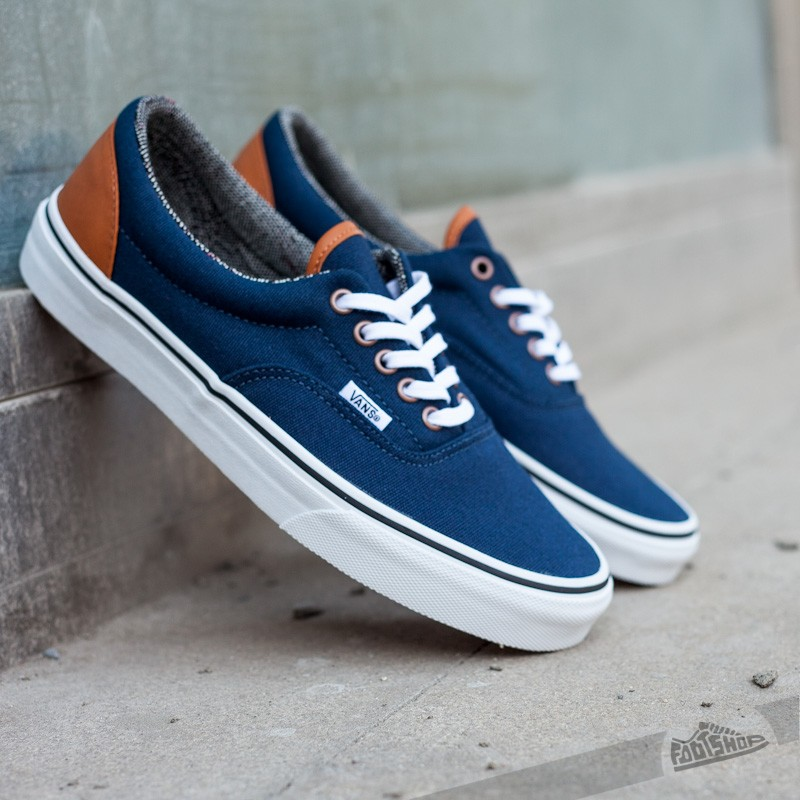Imagine these sneakers are empowered with self-lacing capabilities. What futuristic features could they have besides self-lacing? In a futuristic world where these sneakers have self-lacing capabilities, they could be equipped with several other high-tech features. For instance, imagine built-in temperature regulation, keeping your feet warm in winter and cool in summer through innovative materials and sensors. Additionally, they could have smart insoles that provide real-time feedback on your posture and gait, potentially paired with a connected app that offers personalized health insights and recommendations. Another feature could include adaptive cushioning, adjusting the level of support based on your activity level throughout the day. Lastly, built-in LED lights could allow for customization of colors and patterns, offering both style and safety for nighttime visibility. 